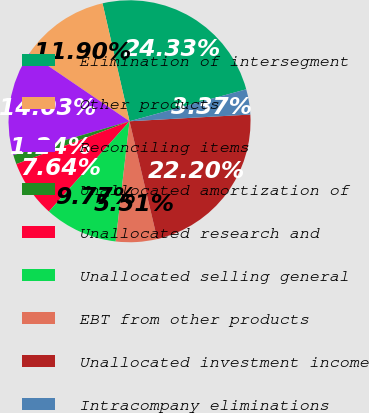Convert chart to OTSL. <chart><loc_0><loc_0><loc_500><loc_500><pie_chart><fcel>Elimination of intersegment<fcel>Other products<fcel>Reconciling items<fcel>Unallocated amortization of<fcel>Unallocated research and<fcel>Unallocated selling general<fcel>EBT from other products<fcel>Unallocated investment income<fcel>Intracompany eliminations<nl><fcel>24.33%<fcel>11.9%<fcel>14.03%<fcel>1.24%<fcel>7.64%<fcel>9.77%<fcel>5.51%<fcel>22.2%<fcel>3.37%<nl></chart> 